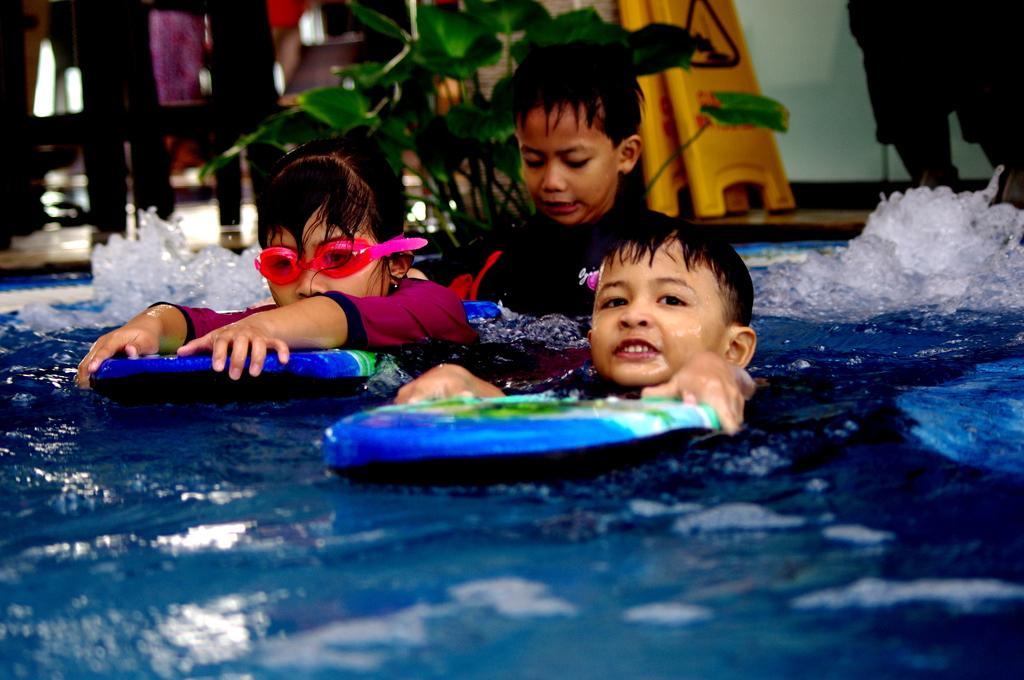Describe this image in one or two sentences. In this picture there are three persons swimming in the water. At the back there is a person standing and there is a plant and board on the floor. 